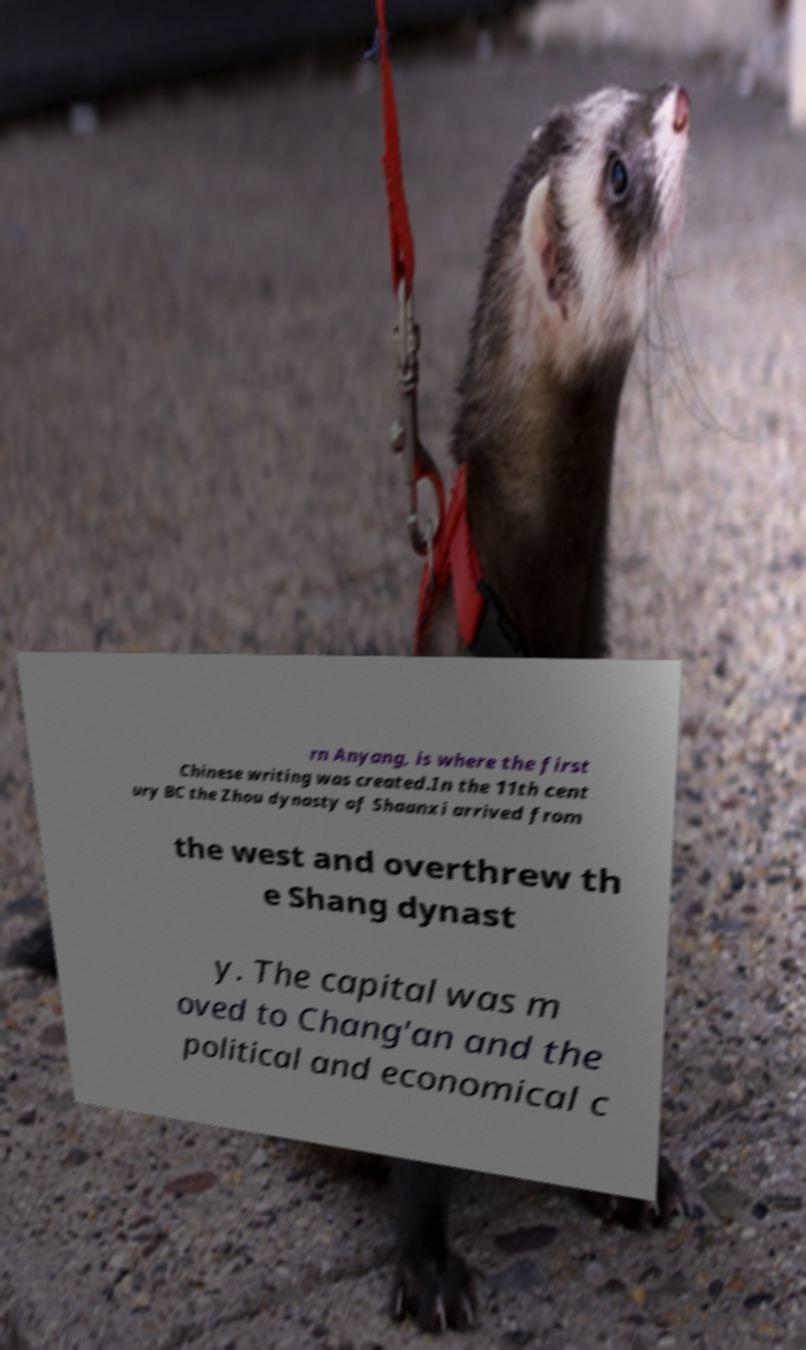Please read and relay the text visible in this image. What does it say? rn Anyang, is where the first Chinese writing was created.In the 11th cent ury BC the Zhou dynasty of Shaanxi arrived from the west and overthrew th e Shang dynast y. The capital was m oved to Chang'an and the political and economical c 